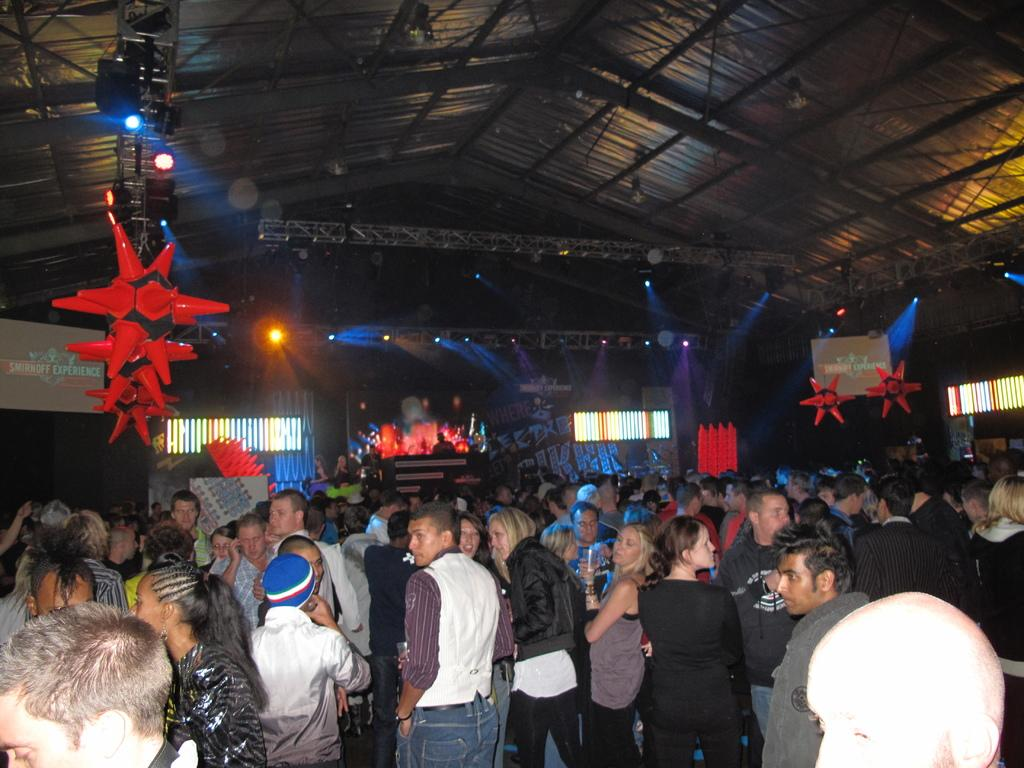What is the main subject of the image? The main subject of the image is a crowd. What can be seen on the ceiling in the image? There are lights on the ceiling in the image. What objects are present in the image that resemble long, thin bars? There are rods in the image. What additional decorative elements can be seen in the image? There are decorations in the image. What type of lighting is present in the background of the image? There are lights on the walls in the background of the image. What is the rate at which the banana is being consumed by the crowd in the image? There is no banana present in the image, so it is not possible to determine the rate at which it is being consumed. What type of star can be seen in the image? There is no star present in the image. 